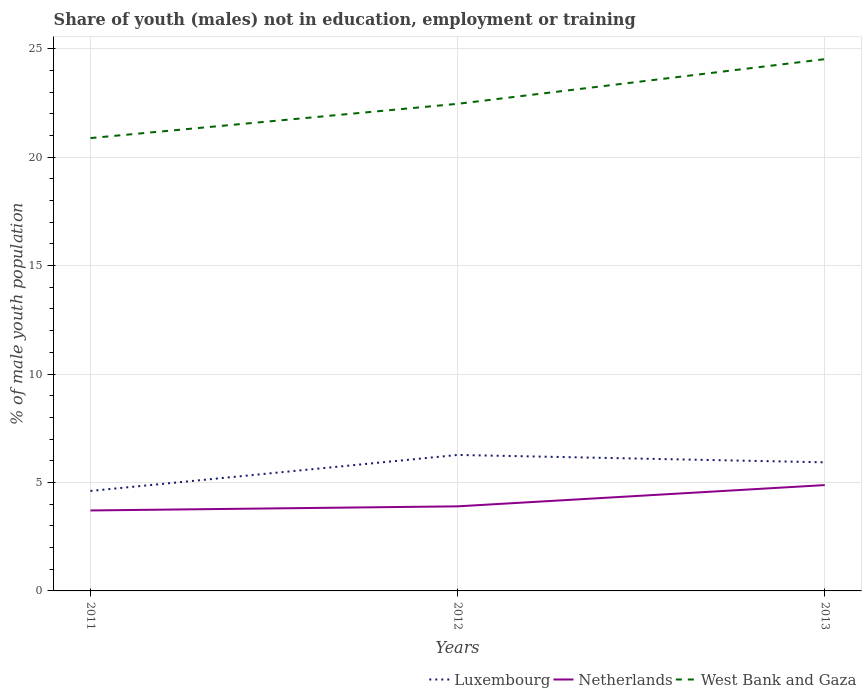Is the number of lines equal to the number of legend labels?
Make the answer very short. Yes. Across all years, what is the maximum percentage of unemployed males population in in West Bank and Gaza?
Your response must be concise. 20.88. What is the total percentage of unemployed males population in in Netherlands in the graph?
Provide a short and direct response. -1.17. What is the difference between the highest and the second highest percentage of unemployed males population in in Luxembourg?
Provide a succinct answer. 1.66. Is the percentage of unemployed males population in in Netherlands strictly greater than the percentage of unemployed males population in in West Bank and Gaza over the years?
Provide a short and direct response. Yes. What is the difference between two consecutive major ticks on the Y-axis?
Make the answer very short. 5. Are the values on the major ticks of Y-axis written in scientific E-notation?
Give a very brief answer. No. Does the graph contain grids?
Keep it short and to the point. Yes. How many legend labels are there?
Offer a very short reply. 3. What is the title of the graph?
Make the answer very short. Share of youth (males) not in education, employment or training. What is the label or title of the X-axis?
Provide a short and direct response. Years. What is the label or title of the Y-axis?
Make the answer very short. % of male youth population. What is the % of male youth population of Luxembourg in 2011?
Provide a succinct answer. 4.61. What is the % of male youth population in Netherlands in 2011?
Give a very brief answer. 3.71. What is the % of male youth population in West Bank and Gaza in 2011?
Provide a succinct answer. 20.88. What is the % of male youth population in Luxembourg in 2012?
Your answer should be very brief. 6.27. What is the % of male youth population of Netherlands in 2012?
Offer a very short reply. 3.9. What is the % of male youth population in West Bank and Gaza in 2012?
Make the answer very short. 22.46. What is the % of male youth population of Luxembourg in 2013?
Your answer should be very brief. 5.93. What is the % of male youth population of Netherlands in 2013?
Provide a succinct answer. 4.88. What is the % of male youth population in West Bank and Gaza in 2013?
Make the answer very short. 24.52. Across all years, what is the maximum % of male youth population of Luxembourg?
Give a very brief answer. 6.27. Across all years, what is the maximum % of male youth population in Netherlands?
Your answer should be compact. 4.88. Across all years, what is the maximum % of male youth population of West Bank and Gaza?
Offer a terse response. 24.52. Across all years, what is the minimum % of male youth population of Luxembourg?
Keep it short and to the point. 4.61. Across all years, what is the minimum % of male youth population in Netherlands?
Make the answer very short. 3.71. Across all years, what is the minimum % of male youth population of West Bank and Gaza?
Provide a short and direct response. 20.88. What is the total % of male youth population of Luxembourg in the graph?
Make the answer very short. 16.81. What is the total % of male youth population of Netherlands in the graph?
Your answer should be very brief. 12.49. What is the total % of male youth population in West Bank and Gaza in the graph?
Offer a terse response. 67.86. What is the difference between the % of male youth population of Luxembourg in 2011 and that in 2012?
Your answer should be compact. -1.66. What is the difference between the % of male youth population in Netherlands in 2011 and that in 2012?
Make the answer very short. -0.19. What is the difference between the % of male youth population of West Bank and Gaza in 2011 and that in 2012?
Keep it short and to the point. -1.58. What is the difference between the % of male youth population of Luxembourg in 2011 and that in 2013?
Ensure brevity in your answer.  -1.32. What is the difference between the % of male youth population of Netherlands in 2011 and that in 2013?
Ensure brevity in your answer.  -1.17. What is the difference between the % of male youth population of West Bank and Gaza in 2011 and that in 2013?
Ensure brevity in your answer.  -3.64. What is the difference between the % of male youth population of Luxembourg in 2012 and that in 2013?
Your response must be concise. 0.34. What is the difference between the % of male youth population of Netherlands in 2012 and that in 2013?
Ensure brevity in your answer.  -0.98. What is the difference between the % of male youth population in West Bank and Gaza in 2012 and that in 2013?
Make the answer very short. -2.06. What is the difference between the % of male youth population of Luxembourg in 2011 and the % of male youth population of Netherlands in 2012?
Keep it short and to the point. 0.71. What is the difference between the % of male youth population in Luxembourg in 2011 and the % of male youth population in West Bank and Gaza in 2012?
Provide a short and direct response. -17.85. What is the difference between the % of male youth population of Netherlands in 2011 and the % of male youth population of West Bank and Gaza in 2012?
Your answer should be compact. -18.75. What is the difference between the % of male youth population of Luxembourg in 2011 and the % of male youth population of Netherlands in 2013?
Keep it short and to the point. -0.27. What is the difference between the % of male youth population of Luxembourg in 2011 and the % of male youth population of West Bank and Gaza in 2013?
Provide a succinct answer. -19.91. What is the difference between the % of male youth population in Netherlands in 2011 and the % of male youth population in West Bank and Gaza in 2013?
Provide a short and direct response. -20.81. What is the difference between the % of male youth population in Luxembourg in 2012 and the % of male youth population in Netherlands in 2013?
Give a very brief answer. 1.39. What is the difference between the % of male youth population of Luxembourg in 2012 and the % of male youth population of West Bank and Gaza in 2013?
Your answer should be compact. -18.25. What is the difference between the % of male youth population of Netherlands in 2012 and the % of male youth population of West Bank and Gaza in 2013?
Keep it short and to the point. -20.62. What is the average % of male youth population of Luxembourg per year?
Give a very brief answer. 5.6. What is the average % of male youth population in Netherlands per year?
Make the answer very short. 4.16. What is the average % of male youth population of West Bank and Gaza per year?
Offer a very short reply. 22.62. In the year 2011, what is the difference between the % of male youth population of Luxembourg and % of male youth population of Netherlands?
Your response must be concise. 0.9. In the year 2011, what is the difference between the % of male youth population in Luxembourg and % of male youth population in West Bank and Gaza?
Your response must be concise. -16.27. In the year 2011, what is the difference between the % of male youth population of Netherlands and % of male youth population of West Bank and Gaza?
Your answer should be compact. -17.17. In the year 2012, what is the difference between the % of male youth population in Luxembourg and % of male youth population in Netherlands?
Give a very brief answer. 2.37. In the year 2012, what is the difference between the % of male youth population of Luxembourg and % of male youth population of West Bank and Gaza?
Offer a terse response. -16.19. In the year 2012, what is the difference between the % of male youth population of Netherlands and % of male youth population of West Bank and Gaza?
Provide a short and direct response. -18.56. In the year 2013, what is the difference between the % of male youth population in Luxembourg and % of male youth population in West Bank and Gaza?
Keep it short and to the point. -18.59. In the year 2013, what is the difference between the % of male youth population of Netherlands and % of male youth population of West Bank and Gaza?
Provide a succinct answer. -19.64. What is the ratio of the % of male youth population in Luxembourg in 2011 to that in 2012?
Your answer should be very brief. 0.74. What is the ratio of the % of male youth population of Netherlands in 2011 to that in 2012?
Provide a succinct answer. 0.95. What is the ratio of the % of male youth population in West Bank and Gaza in 2011 to that in 2012?
Make the answer very short. 0.93. What is the ratio of the % of male youth population of Luxembourg in 2011 to that in 2013?
Provide a succinct answer. 0.78. What is the ratio of the % of male youth population in Netherlands in 2011 to that in 2013?
Ensure brevity in your answer.  0.76. What is the ratio of the % of male youth population in West Bank and Gaza in 2011 to that in 2013?
Offer a very short reply. 0.85. What is the ratio of the % of male youth population in Luxembourg in 2012 to that in 2013?
Offer a very short reply. 1.06. What is the ratio of the % of male youth population of Netherlands in 2012 to that in 2013?
Offer a terse response. 0.8. What is the ratio of the % of male youth population of West Bank and Gaza in 2012 to that in 2013?
Your response must be concise. 0.92. What is the difference between the highest and the second highest % of male youth population in Luxembourg?
Make the answer very short. 0.34. What is the difference between the highest and the second highest % of male youth population in West Bank and Gaza?
Provide a succinct answer. 2.06. What is the difference between the highest and the lowest % of male youth population of Luxembourg?
Ensure brevity in your answer.  1.66. What is the difference between the highest and the lowest % of male youth population in Netherlands?
Keep it short and to the point. 1.17. What is the difference between the highest and the lowest % of male youth population of West Bank and Gaza?
Your answer should be very brief. 3.64. 